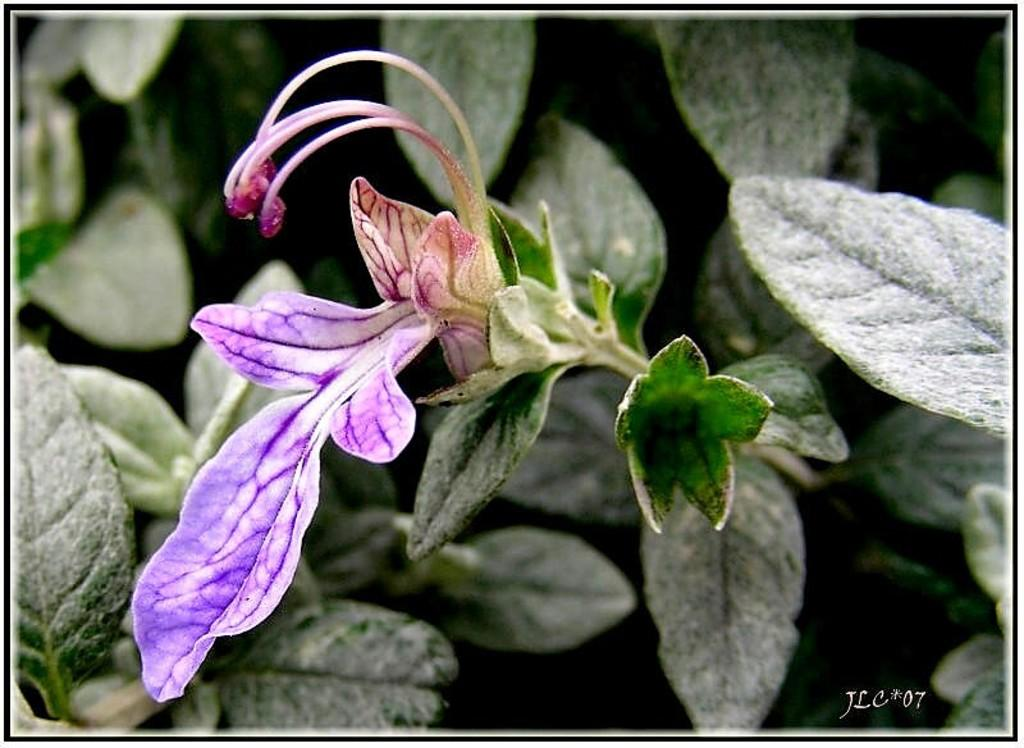What type of living organism is present in the image? There is a plant in the image. What specific part of the plant can be seen in the image? There is a flower on the plant. What is the function of the stigma in the flower? The flower has a stigma, which is a part of the plant's reproductive system. What else is present on the plant besides the flower? There are leaves on the plant. What type of competition is the plant participating in within the image? There is no competition present in the image; it is a plant with a flower and leaves. What type of servant might be associated with the plant in the image? There is no servant associated with the plant in the image; it is a plant with a flower and leaves. 